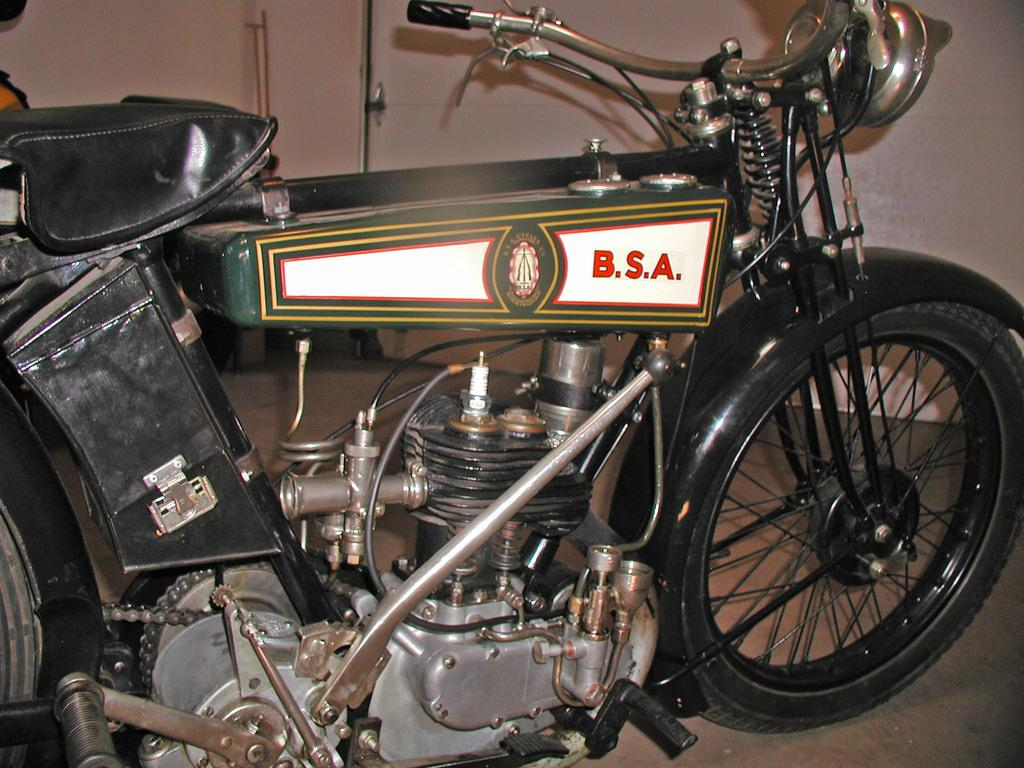What is the main object in the image? There is a bike in the image. What else can be seen in the image besides the bike? There is text on a white background in the image. What is visible in the background of the image? There is a wall in the background of the image. How many toads can be seen on the bike in the image? There are no toads present in the image. What year is depicted in the text on the white background? The provided facts do not mention any specific year in the text, so it cannot be determined from the image. 